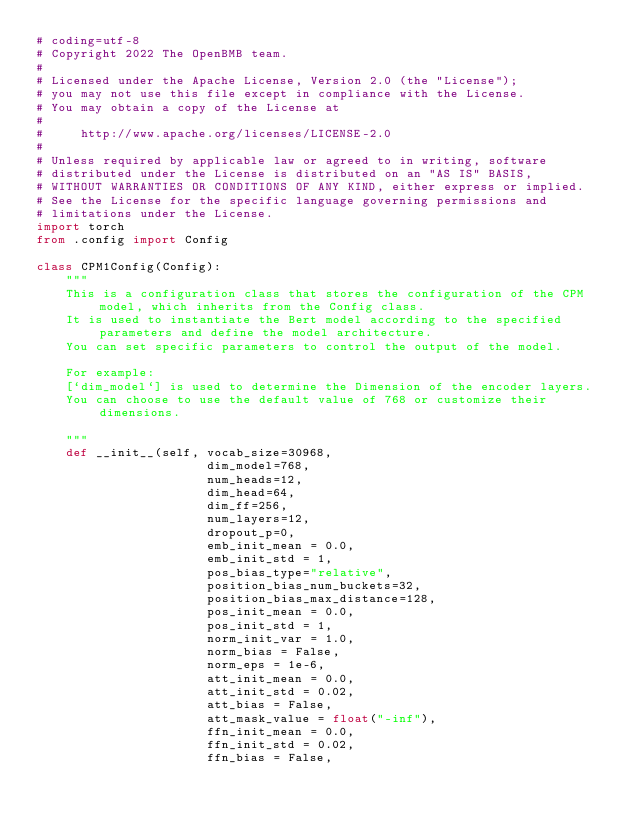<code> <loc_0><loc_0><loc_500><loc_500><_Python_># coding=utf-8
# Copyright 2022 The OpenBMB team.
#
# Licensed under the Apache License, Version 2.0 (the "License");
# you may not use this file except in compliance with the License.
# You may obtain a copy of the License at
#
#     http://www.apache.org/licenses/LICENSE-2.0
#
# Unless required by applicable law or agreed to in writing, software
# distributed under the License is distributed on an "AS IS" BASIS,
# WITHOUT WARRANTIES OR CONDITIONS OF ANY KIND, either express or implied.
# See the License for the specific language governing permissions and
# limitations under the License.
import torch
from .config import Config

class CPM1Config(Config):
    """
    This is a configuration class that stores the configuration of the CPM model, which inherits from the Config class.
    It is used to instantiate the Bert model according to the specified parameters and define the model architecture.
    You can set specific parameters to control the output of the model.

    For example:
    [`dim_model`] is used to determine the Dimension of the encoder layers.
    You can choose to use the default value of 768 or customize their dimensions.  
    
    """
    def __init__(self, vocab_size=30968,
                       dim_model=768,
                       num_heads=12,
                       dim_head=64,
                       dim_ff=256,
                       num_layers=12,
                       dropout_p=0,
                       emb_init_mean = 0.0,
                       emb_init_std = 1,
                       pos_bias_type="relative",
                       position_bias_num_buckets=32, 
                       position_bias_max_distance=128, 
                       pos_init_mean = 0.0,
                       pos_init_std = 1,
                       norm_init_var = 1.0,
                       norm_bias = False,
                       norm_eps = 1e-6,
                       att_init_mean = 0.0, 
                       att_init_std = 0.02,
                       att_bias = False,
                       att_mask_value = float("-inf"),
                       ffn_init_mean = 0.0, 
                       ffn_init_std = 0.02,
                       ffn_bias = False,</code> 